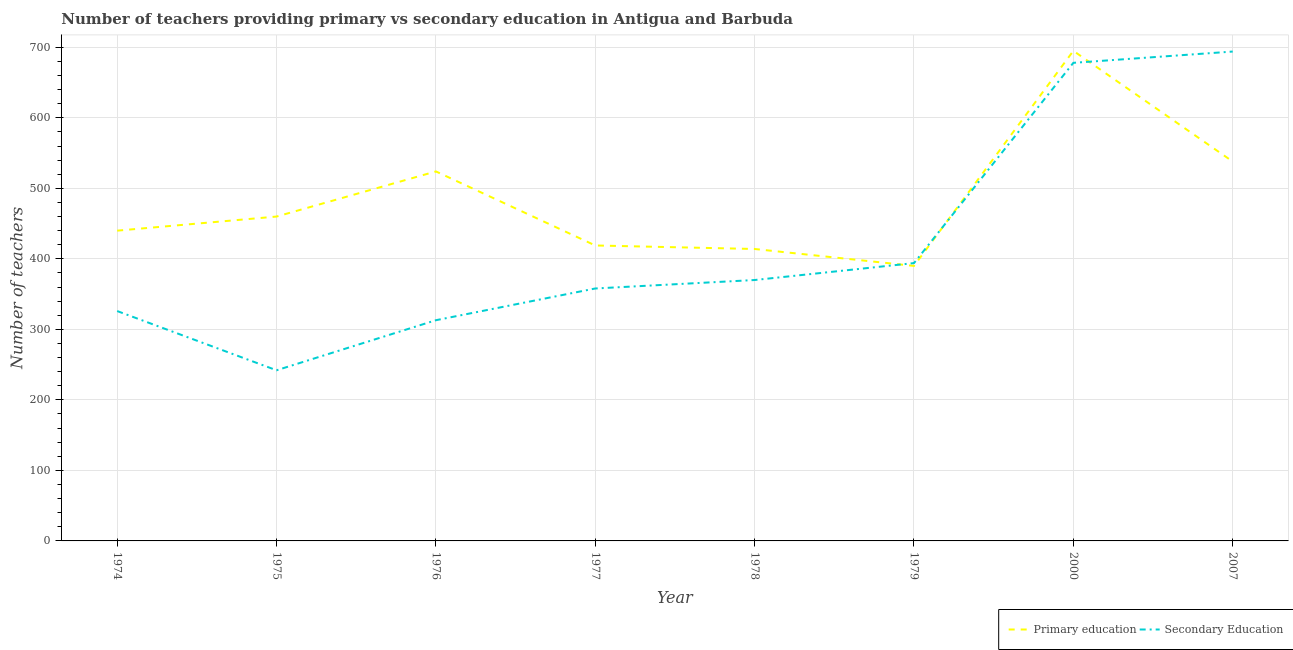Does the line corresponding to number of primary teachers intersect with the line corresponding to number of secondary teachers?
Make the answer very short. Yes. Is the number of lines equal to the number of legend labels?
Provide a succinct answer. Yes. What is the number of primary teachers in 1979?
Offer a terse response. 390. Across all years, what is the maximum number of secondary teachers?
Ensure brevity in your answer.  694. Across all years, what is the minimum number of secondary teachers?
Give a very brief answer. 242. In which year was the number of secondary teachers minimum?
Make the answer very short. 1975. What is the total number of secondary teachers in the graph?
Your answer should be compact. 3375. What is the difference between the number of secondary teachers in 1974 and that in 1975?
Provide a succinct answer. 84. What is the difference between the number of secondary teachers in 1974 and the number of primary teachers in 1978?
Your response must be concise. -88. What is the average number of secondary teachers per year?
Offer a terse response. 421.88. In the year 2007, what is the difference between the number of secondary teachers and number of primary teachers?
Make the answer very short. 156. In how many years, is the number of secondary teachers greater than 620?
Ensure brevity in your answer.  2. What is the ratio of the number of primary teachers in 1978 to that in 2000?
Your answer should be compact. 0.6. What is the difference between the highest and the lowest number of primary teachers?
Your answer should be very brief. 305. In how many years, is the number of secondary teachers greater than the average number of secondary teachers taken over all years?
Your answer should be very brief. 2. Is the sum of the number of secondary teachers in 1974 and 1976 greater than the maximum number of primary teachers across all years?
Give a very brief answer. No. Does the number of secondary teachers monotonically increase over the years?
Your answer should be very brief. No. How many years are there in the graph?
Make the answer very short. 8. What is the difference between two consecutive major ticks on the Y-axis?
Offer a very short reply. 100. Does the graph contain any zero values?
Provide a succinct answer. No. Does the graph contain grids?
Your answer should be very brief. Yes. How are the legend labels stacked?
Offer a very short reply. Horizontal. What is the title of the graph?
Your answer should be compact. Number of teachers providing primary vs secondary education in Antigua and Barbuda. Does "Under-5(female)" appear as one of the legend labels in the graph?
Your response must be concise. No. What is the label or title of the Y-axis?
Provide a succinct answer. Number of teachers. What is the Number of teachers in Primary education in 1974?
Keep it short and to the point. 440. What is the Number of teachers in Secondary Education in 1974?
Provide a succinct answer. 326. What is the Number of teachers of Primary education in 1975?
Give a very brief answer. 460. What is the Number of teachers in Secondary Education in 1975?
Provide a succinct answer. 242. What is the Number of teachers of Primary education in 1976?
Ensure brevity in your answer.  524. What is the Number of teachers in Secondary Education in 1976?
Offer a terse response. 313. What is the Number of teachers in Primary education in 1977?
Make the answer very short. 419. What is the Number of teachers in Secondary Education in 1977?
Keep it short and to the point. 358. What is the Number of teachers in Primary education in 1978?
Your answer should be compact. 414. What is the Number of teachers in Secondary Education in 1978?
Offer a terse response. 370. What is the Number of teachers of Primary education in 1979?
Your answer should be very brief. 390. What is the Number of teachers of Secondary Education in 1979?
Your answer should be compact. 394. What is the Number of teachers of Primary education in 2000?
Keep it short and to the point. 695. What is the Number of teachers of Secondary Education in 2000?
Make the answer very short. 678. What is the Number of teachers of Primary education in 2007?
Offer a very short reply. 538. What is the Number of teachers in Secondary Education in 2007?
Make the answer very short. 694. Across all years, what is the maximum Number of teachers in Primary education?
Your answer should be compact. 695. Across all years, what is the maximum Number of teachers of Secondary Education?
Make the answer very short. 694. Across all years, what is the minimum Number of teachers in Primary education?
Your response must be concise. 390. Across all years, what is the minimum Number of teachers of Secondary Education?
Ensure brevity in your answer.  242. What is the total Number of teachers in Primary education in the graph?
Your response must be concise. 3880. What is the total Number of teachers of Secondary Education in the graph?
Offer a terse response. 3375. What is the difference between the Number of teachers in Primary education in 1974 and that in 1976?
Provide a succinct answer. -84. What is the difference between the Number of teachers of Secondary Education in 1974 and that in 1977?
Offer a very short reply. -32. What is the difference between the Number of teachers in Secondary Education in 1974 and that in 1978?
Ensure brevity in your answer.  -44. What is the difference between the Number of teachers of Secondary Education in 1974 and that in 1979?
Provide a short and direct response. -68. What is the difference between the Number of teachers of Primary education in 1974 and that in 2000?
Ensure brevity in your answer.  -255. What is the difference between the Number of teachers of Secondary Education in 1974 and that in 2000?
Offer a very short reply. -352. What is the difference between the Number of teachers of Primary education in 1974 and that in 2007?
Offer a very short reply. -98. What is the difference between the Number of teachers of Secondary Education in 1974 and that in 2007?
Offer a terse response. -368. What is the difference between the Number of teachers of Primary education in 1975 and that in 1976?
Keep it short and to the point. -64. What is the difference between the Number of teachers in Secondary Education in 1975 and that in 1976?
Provide a succinct answer. -71. What is the difference between the Number of teachers of Secondary Education in 1975 and that in 1977?
Keep it short and to the point. -116. What is the difference between the Number of teachers of Secondary Education in 1975 and that in 1978?
Your answer should be very brief. -128. What is the difference between the Number of teachers of Primary education in 1975 and that in 1979?
Make the answer very short. 70. What is the difference between the Number of teachers of Secondary Education in 1975 and that in 1979?
Give a very brief answer. -152. What is the difference between the Number of teachers in Primary education in 1975 and that in 2000?
Give a very brief answer. -235. What is the difference between the Number of teachers of Secondary Education in 1975 and that in 2000?
Provide a succinct answer. -436. What is the difference between the Number of teachers of Primary education in 1975 and that in 2007?
Keep it short and to the point. -78. What is the difference between the Number of teachers of Secondary Education in 1975 and that in 2007?
Give a very brief answer. -452. What is the difference between the Number of teachers of Primary education in 1976 and that in 1977?
Make the answer very short. 105. What is the difference between the Number of teachers of Secondary Education in 1976 and that in 1977?
Your answer should be compact. -45. What is the difference between the Number of teachers of Primary education in 1976 and that in 1978?
Provide a succinct answer. 110. What is the difference between the Number of teachers in Secondary Education in 1976 and that in 1978?
Provide a short and direct response. -57. What is the difference between the Number of teachers of Primary education in 1976 and that in 1979?
Your answer should be very brief. 134. What is the difference between the Number of teachers in Secondary Education in 1976 and that in 1979?
Offer a terse response. -81. What is the difference between the Number of teachers of Primary education in 1976 and that in 2000?
Keep it short and to the point. -171. What is the difference between the Number of teachers of Secondary Education in 1976 and that in 2000?
Keep it short and to the point. -365. What is the difference between the Number of teachers of Primary education in 1976 and that in 2007?
Offer a terse response. -14. What is the difference between the Number of teachers of Secondary Education in 1976 and that in 2007?
Make the answer very short. -381. What is the difference between the Number of teachers of Primary education in 1977 and that in 1978?
Offer a terse response. 5. What is the difference between the Number of teachers in Secondary Education in 1977 and that in 1978?
Provide a succinct answer. -12. What is the difference between the Number of teachers of Secondary Education in 1977 and that in 1979?
Make the answer very short. -36. What is the difference between the Number of teachers of Primary education in 1977 and that in 2000?
Offer a terse response. -276. What is the difference between the Number of teachers of Secondary Education in 1977 and that in 2000?
Provide a succinct answer. -320. What is the difference between the Number of teachers of Primary education in 1977 and that in 2007?
Your answer should be very brief. -119. What is the difference between the Number of teachers of Secondary Education in 1977 and that in 2007?
Ensure brevity in your answer.  -336. What is the difference between the Number of teachers of Secondary Education in 1978 and that in 1979?
Give a very brief answer. -24. What is the difference between the Number of teachers of Primary education in 1978 and that in 2000?
Give a very brief answer. -281. What is the difference between the Number of teachers of Secondary Education in 1978 and that in 2000?
Your answer should be very brief. -308. What is the difference between the Number of teachers in Primary education in 1978 and that in 2007?
Keep it short and to the point. -124. What is the difference between the Number of teachers of Secondary Education in 1978 and that in 2007?
Offer a terse response. -324. What is the difference between the Number of teachers of Primary education in 1979 and that in 2000?
Offer a terse response. -305. What is the difference between the Number of teachers in Secondary Education in 1979 and that in 2000?
Keep it short and to the point. -284. What is the difference between the Number of teachers in Primary education in 1979 and that in 2007?
Offer a terse response. -148. What is the difference between the Number of teachers in Secondary Education in 1979 and that in 2007?
Provide a short and direct response. -300. What is the difference between the Number of teachers of Primary education in 2000 and that in 2007?
Your answer should be compact. 157. What is the difference between the Number of teachers in Primary education in 1974 and the Number of teachers in Secondary Education in 1975?
Your response must be concise. 198. What is the difference between the Number of teachers in Primary education in 1974 and the Number of teachers in Secondary Education in 1976?
Offer a terse response. 127. What is the difference between the Number of teachers in Primary education in 1974 and the Number of teachers in Secondary Education in 1977?
Provide a succinct answer. 82. What is the difference between the Number of teachers in Primary education in 1974 and the Number of teachers in Secondary Education in 1979?
Your answer should be very brief. 46. What is the difference between the Number of teachers of Primary education in 1974 and the Number of teachers of Secondary Education in 2000?
Provide a succinct answer. -238. What is the difference between the Number of teachers in Primary education in 1974 and the Number of teachers in Secondary Education in 2007?
Make the answer very short. -254. What is the difference between the Number of teachers of Primary education in 1975 and the Number of teachers of Secondary Education in 1976?
Provide a short and direct response. 147. What is the difference between the Number of teachers in Primary education in 1975 and the Number of teachers in Secondary Education in 1977?
Provide a short and direct response. 102. What is the difference between the Number of teachers of Primary education in 1975 and the Number of teachers of Secondary Education in 2000?
Give a very brief answer. -218. What is the difference between the Number of teachers of Primary education in 1975 and the Number of teachers of Secondary Education in 2007?
Offer a very short reply. -234. What is the difference between the Number of teachers in Primary education in 1976 and the Number of teachers in Secondary Education in 1977?
Your answer should be very brief. 166. What is the difference between the Number of teachers in Primary education in 1976 and the Number of teachers in Secondary Education in 1978?
Keep it short and to the point. 154. What is the difference between the Number of teachers of Primary education in 1976 and the Number of teachers of Secondary Education in 1979?
Offer a very short reply. 130. What is the difference between the Number of teachers in Primary education in 1976 and the Number of teachers in Secondary Education in 2000?
Offer a terse response. -154. What is the difference between the Number of teachers of Primary education in 1976 and the Number of teachers of Secondary Education in 2007?
Your answer should be very brief. -170. What is the difference between the Number of teachers of Primary education in 1977 and the Number of teachers of Secondary Education in 1978?
Give a very brief answer. 49. What is the difference between the Number of teachers of Primary education in 1977 and the Number of teachers of Secondary Education in 2000?
Ensure brevity in your answer.  -259. What is the difference between the Number of teachers in Primary education in 1977 and the Number of teachers in Secondary Education in 2007?
Provide a short and direct response. -275. What is the difference between the Number of teachers of Primary education in 1978 and the Number of teachers of Secondary Education in 2000?
Offer a very short reply. -264. What is the difference between the Number of teachers of Primary education in 1978 and the Number of teachers of Secondary Education in 2007?
Your answer should be compact. -280. What is the difference between the Number of teachers in Primary education in 1979 and the Number of teachers in Secondary Education in 2000?
Provide a short and direct response. -288. What is the difference between the Number of teachers of Primary education in 1979 and the Number of teachers of Secondary Education in 2007?
Ensure brevity in your answer.  -304. What is the difference between the Number of teachers in Primary education in 2000 and the Number of teachers in Secondary Education in 2007?
Keep it short and to the point. 1. What is the average Number of teachers in Primary education per year?
Offer a very short reply. 485. What is the average Number of teachers in Secondary Education per year?
Provide a short and direct response. 421.88. In the year 1974, what is the difference between the Number of teachers of Primary education and Number of teachers of Secondary Education?
Provide a succinct answer. 114. In the year 1975, what is the difference between the Number of teachers of Primary education and Number of teachers of Secondary Education?
Keep it short and to the point. 218. In the year 1976, what is the difference between the Number of teachers in Primary education and Number of teachers in Secondary Education?
Provide a succinct answer. 211. In the year 1977, what is the difference between the Number of teachers in Primary education and Number of teachers in Secondary Education?
Offer a terse response. 61. In the year 1978, what is the difference between the Number of teachers in Primary education and Number of teachers in Secondary Education?
Keep it short and to the point. 44. In the year 2000, what is the difference between the Number of teachers in Primary education and Number of teachers in Secondary Education?
Give a very brief answer. 17. In the year 2007, what is the difference between the Number of teachers of Primary education and Number of teachers of Secondary Education?
Offer a very short reply. -156. What is the ratio of the Number of teachers of Primary education in 1974 to that in 1975?
Keep it short and to the point. 0.96. What is the ratio of the Number of teachers in Secondary Education in 1974 to that in 1975?
Your answer should be very brief. 1.35. What is the ratio of the Number of teachers in Primary education in 1974 to that in 1976?
Offer a very short reply. 0.84. What is the ratio of the Number of teachers of Secondary Education in 1974 to that in 1976?
Give a very brief answer. 1.04. What is the ratio of the Number of teachers in Primary education in 1974 to that in 1977?
Your answer should be compact. 1.05. What is the ratio of the Number of teachers of Secondary Education in 1974 to that in 1977?
Give a very brief answer. 0.91. What is the ratio of the Number of teachers in Primary education in 1974 to that in 1978?
Your answer should be very brief. 1.06. What is the ratio of the Number of teachers in Secondary Education in 1974 to that in 1978?
Provide a short and direct response. 0.88. What is the ratio of the Number of teachers of Primary education in 1974 to that in 1979?
Your response must be concise. 1.13. What is the ratio of the Number of teachers in Secondary Education in 1974 to that in 1979?
Your answer should be very brief. 0.83. What is the ratio of the Number of teachers of Primary education in 1974 to that in 2000?
Keep it short and to the point. 0.63. What is the ratio of the Number of teachers of Secondary Education in 1974 to that in 2000?
Offer a very short reply. 0.48. What is the ratio of the Number of teachers in Primary education in 1974 to that in 2007?
Give a very brief answer. 0.82. What is the ratio of the Number of teachers in Secondary Education in 1974 to that in 2007?
Make the answer very short. 0.47. What is the ratio of the Number of teachers of Primary education in 1975 to that in 1976?
Your response must be concise. 0.88. What is the ratio of the Number of teachers in Secondary Education in 1975 to that in 1976?
Your response must be concise. 0.77. What is the ratio of the Number of teachers of Primary education in 1975 to that in 1977?
Keep it short and to the point. 1.1. What is the ratio of the Number of teachers of Secondary Education in 1975 to that in 1977?
Give a very brief answer. 0.68. What is the ratio of the Number of teachers in Secondary Education in 1975 to that in 1978?
Your answer should be very brief. 0.65. What is the ratio of the Number of teachers of Primary education in 1975 to that in 1979?
Offer a very short reply. 1.18. What is the ratio of the Number of teachers in Secondary Education in 1975 to that in 1979?
Ensure brevity in your answer.  0.61. What is the ratio of the Number of teachers of Primary education in 1975 to that in 2000?
Your response must be concise. 0.66. What is the ratio of the Number of teachers of Secondary Education in 1975 to that in 2000?
Give a very brief answer. 0.36. What is the ratio of the Number of teachers of Primary education in 1975 to that in 2007?
Make the answer very short. 0.85. What is the ratio of the Number of teachers of Secondary Education in 1975 to that in 2007?
Your response must be concise. 0.35. What is the ratio of the Number of teachers of Primary education in 1976 to that in 1977?
Your answer should be compact. 1.25. What is the ratio of the Number of teachers in Secondary Education in 1976 to that in 1977?
Your answer should be compact. 0.87. What is the ratio of the Number of teachers in Primary education in 1976 to that in 1978?
Your response must be concise. 1.27. What is the ratio of the Number of teachers of Secondary Education in 1976 to that in 1978?
Your response must be concise. 0.85. What is the ratio of the Number of teachers of Primary education in 1976 to that in 1979?
Offer a very short reply. 1.34. What is the ratio of the Number of teachers in Secondary Education in 1976 to that in 1979?
Provide a short and direct response. 0.79. What is the ratio of the Number of teachers in Primary education in 1976 to that in 2000?
Your answer should be compact. 0.75. What is the ratio of the Number of teachers of Secondary Education in 1976 to that in 2000?
Provide a short and direct response. 0.46. What is the ratio of the Number of teachers of Primary education in 1976 to that in 2007?
Your response must be concise. 0.97. What is the ratio of the Number of teachers in Secondary Education in 1976 to that in 2007?
Provide a succinct answer. 0.45. What is the ratio of the Number of teachers of Primary education in 1977 to that in 1978?
Your response must be concise. 1.01. What is the ratio of the Number of teachers in Secondary Education in 1977 to that in 1978?
Provide a short and direct response. 0.97. What is the ratio of the Number of teachers in Primary education in 1977 to that in 1979?
Make the answer very short. 1.07. What is the ratio of the Number of teachers in Secondary Education in 1977 to that in 1979?
Your response must be concise. 0.91. What is the ratio of the Number of teachers in Primary education in 1977 to that in 2000?
Give a very brief answer. 0.6. What is the ratio of the Number of teachers in Secondary Education in 1977 to that in 2000?
Keep it short and to the point. 0.53. What is the ratio of the Number of teachers of Primary education in 1977 to that in 2007?
Provide a succinct answer. 0.78. What is the ratio of the Number of teachers in Secondary Education in 1977 to that in 2007?
Offer a very short reply. 0.52. What is the ratio of the Number of teachers of Primary education in 1978 to that in 1979?
Offer a very short reply. 1.06. What is the ratio of the Number of teachers of Secondary Education in 1978 to that in 1979?
Give a very brief answer. 0.94. What is the ratio of the Number of teachers in Primary education in 1978 to that in 2000?
Your answer should be compact. 0.6. What is the ratio of the Number of teachers of Secondary Education in 1978 to that in 2000?
Provide a succinct answer. 0.55. What is the ratio of the Number of teachers in Primary education in 1978 to that in 2007?
Offer a terse response. 0.77. What is the ratio of the Number of teachers in Secondary Education in 1978 to that in 2007?
Make the answer very short. 0.53. What is the ratio of the Number of teachers in Primary education in 1979 to that in 2000?
Ensure brevity in your answer.  0.56. What is the ratio of the Number of teachers of Secondary Education in 1979 to that in 2000?
Make the answer very short. 0.58. What is the ratio of the Number of teachers of Primary education in 1979 to that in 2007?
Offer a terse response. 0.72. What is the ratio of the Number of teachers in Secondary Education in 1979 to that in 2007?
Offer a very short reply. 0.57. What is the ratio of the Number of teachers of Primary education in 2000 to that in 2007?
Your response must be concise. 1.29. What is the ratio of the Number of teachers in Secondary Education in 2000 to that in 2007?
Keep it short and to the point. 0.98. What is the difference between the highest and the second highest Number of teachers of Primary education?
Offer a very short reply. 157. What is the difference between the highest and the second highest Number of teachers of Secondary Education?
Make the answer very short. 16. What is the difference between the highest and the lowest Number of teachers in Primary education?
Provide a succinct answer. 305. What is the difference between the highest and the lowest Number of teachers of Secondary Education?
Ensure brevity in your answer.  452. 